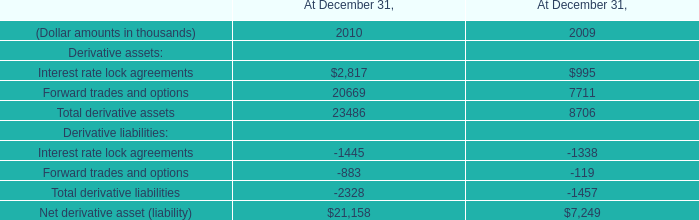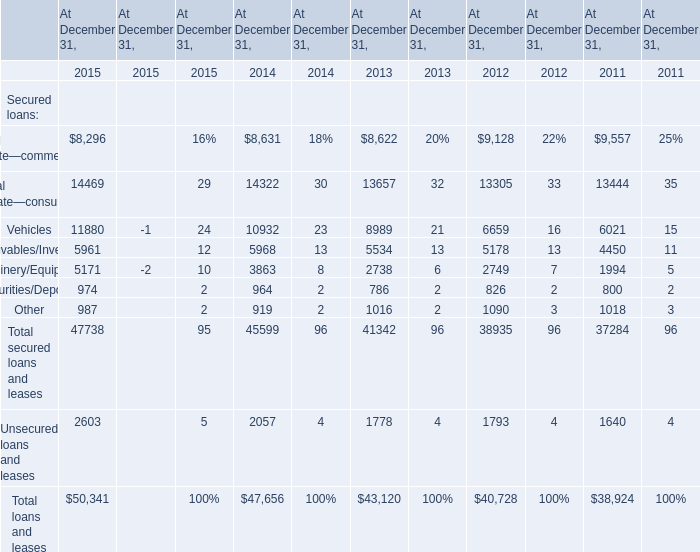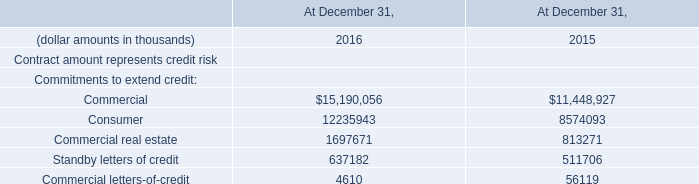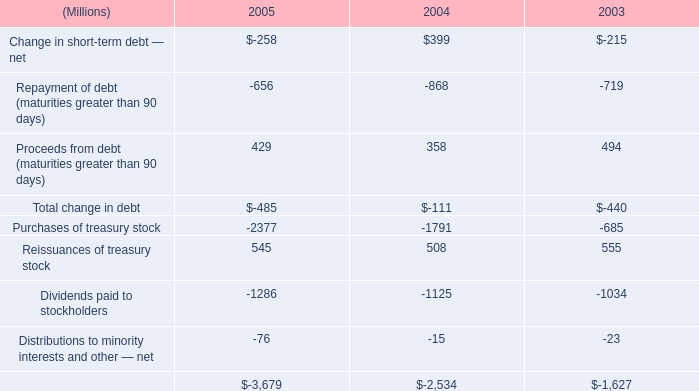what's the total amount of Machinery/Equipment of At December 31, 2015, and Dividends paid to stockholders of 2005 ? 
Computations: (5171.0 + 1286.0)
Answer: 6457.0. 